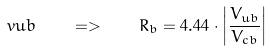<formula> <loc_0><loc_0><loc_500><loc_500>\ v u b \quad = > \quad R _ { b } = 4 . 4 4 \cdot \left | \frac { V _ { u b } } { V _ { c b } } \right |</formula> 